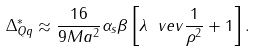<formula> <loc_0><loc_0><loc_500><loc_500>\Delta ^ { * } _ { Q q } \approx \frac { 1 6 } { 9 M a ^ { 2 } } \alpha _ { s } \beta \left [ \lambda \ v e v { \frac { 1 } { \rho ^ { 2 } } } + 1 \right ] .</formula> 